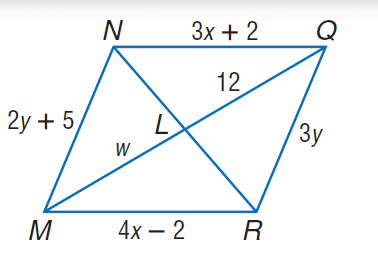Answer the mathemtical geometry problem and directly provide the correct option letter.
Question: Use parallelogram N Q R M to find w.
Choices: A: 4 B: 12 C: 14 D: 29 B 